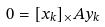<formula> <loc_0><loc_0><loc_500><loc_500>0 = [ x _ { k } ] _ { \times } A y _ { k }</formula> 